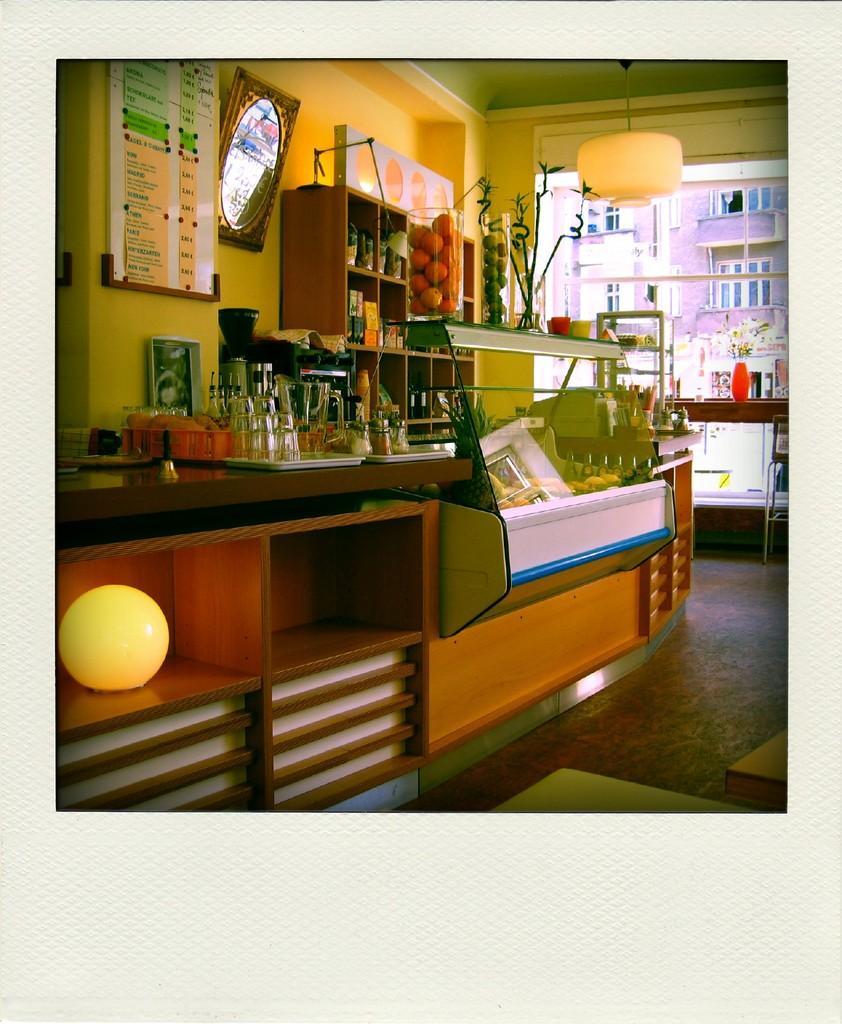Could you give a brief overview of what you see in this image? This image is a photograph. In the center we can see a countertop and there are things placed on the counter top. In the background there is a shelf and we can see bottles placed in the shelf. There are decors and flower vase placed on the table. We can see a chair. There are lights. In the background there is a board and a frame placed on the wall. 